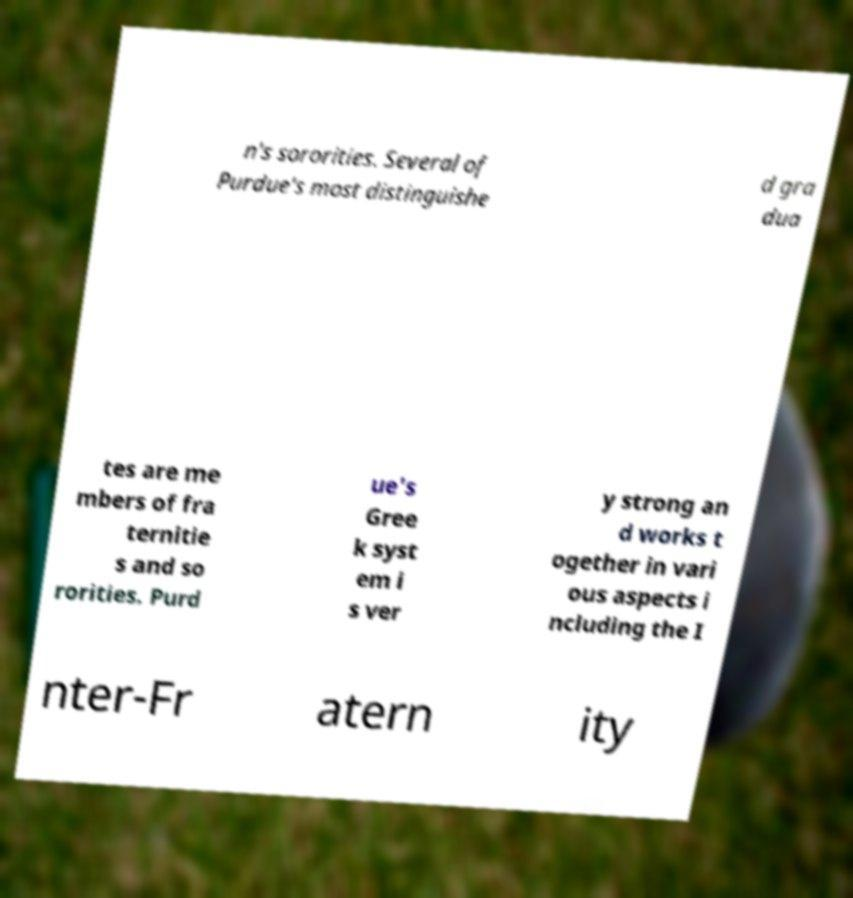Please identify and transcribe the text found in this image. n's sororities. Several of Purdue's most distinguishe d gra dua tes are me mbers of fra ternitie s and so rorities. Purd ue's Gree k syst em i s ver y strong an d works t ogether in vari ous aspects i ncluding the I nter-Fr atern ity 